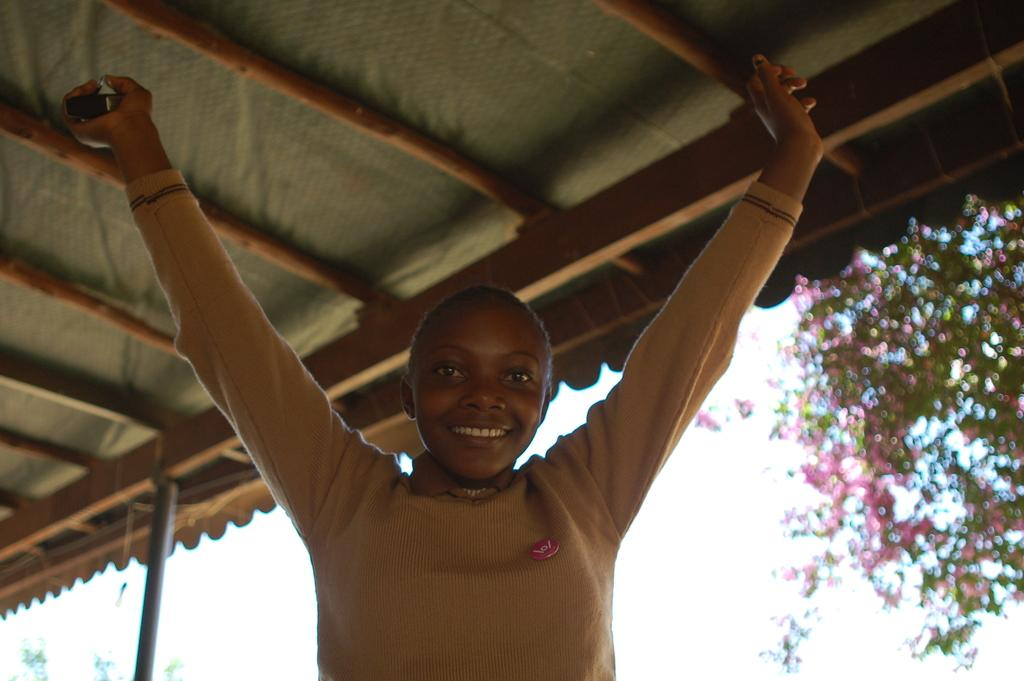Who is present in the image? There is a woman in the image. What type of structure is visible in the image? There is a wooden roof visible in the image. What type of plant can be seen in the image? There is a plant with flowers in the image. What is visible in the background of the image? The sky is visible in the image. What is the weather like in the image? The sky appears to be cloudy in the image. What type of eggs can be seen in the image? There are no eggs present in the image. How does the woman in the image attract the attention of the viewer? The image does not provide information about how the woman attracts the attention of the viewer. 